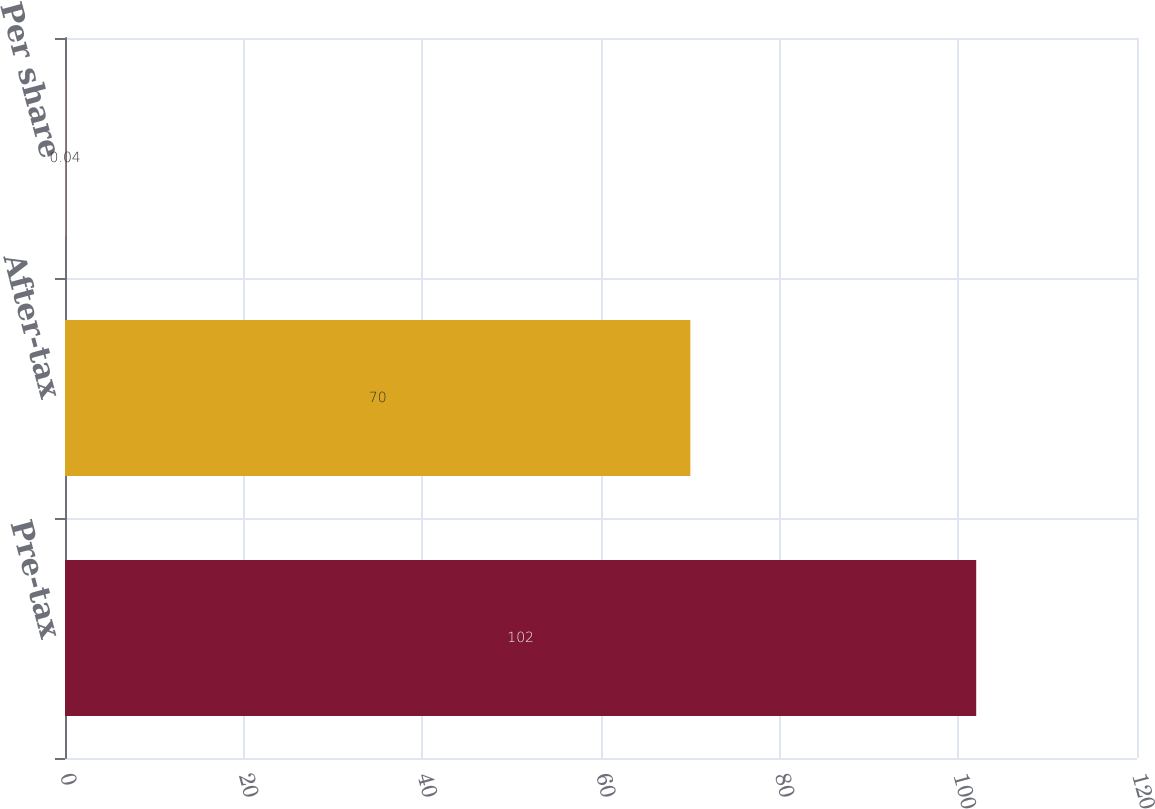Convert chart. <chart><loc_0><loc_0><loc_500><loc_500><bar_chart><fcel>Pre-tax<fcel>After-tax<fcel>Per share<nl><fcel>102<fcel>70<fcel>0.04<nl></chart> 